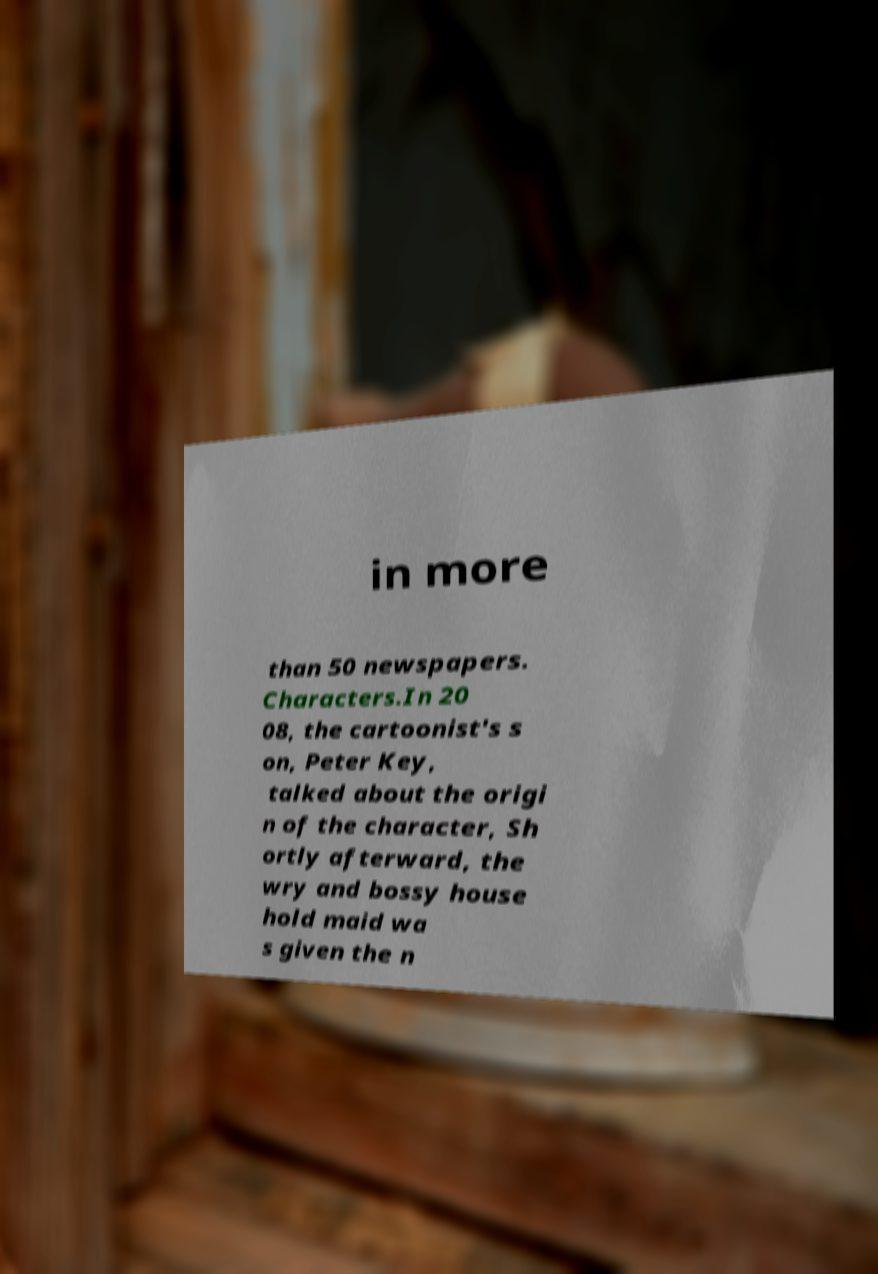Could you extract and type out the text from this image? in more than 50 newspapers. Characters.In 20 08, the cartoonist's s on, Peter Key, talked about the origi n of the character, Sh ortly afterward, the wry and bossy house hold maid wa s given the n 